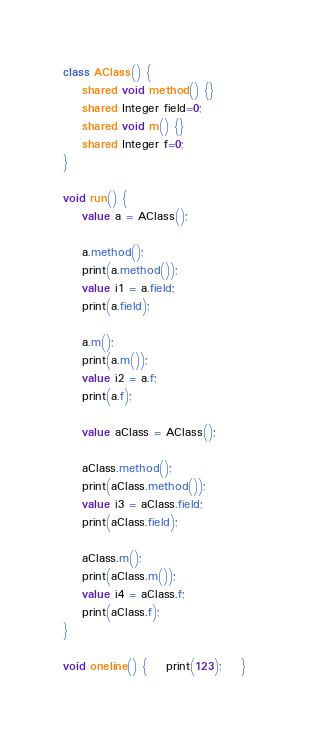Convert code to text. <code><loc_0><loc_0><loc_500><loc_500><_Ceylon_>class AClass() {
    shared void method() {}
    shared Integer field=0;
    shared void m() {}
    shared Integer f=0;
}

void run() {
    value a = AClass();

    a.method();
    print(a.method());
    value i1 = a.field;
    print(a.field);

    a.m();
    print(a.m());
    value i2 = a.f;
    print(a.f);

    value aClass = AClass();

    aClass.method();
    print(aClass.method());
    value i3 = aClass.field;
    print(aClass.field);

    aClass.m();
    print(aClass.m());
    value i4 = aClass.f;
    print(aClass.f);
}

void oneline() {    print(123);    }
</code> 